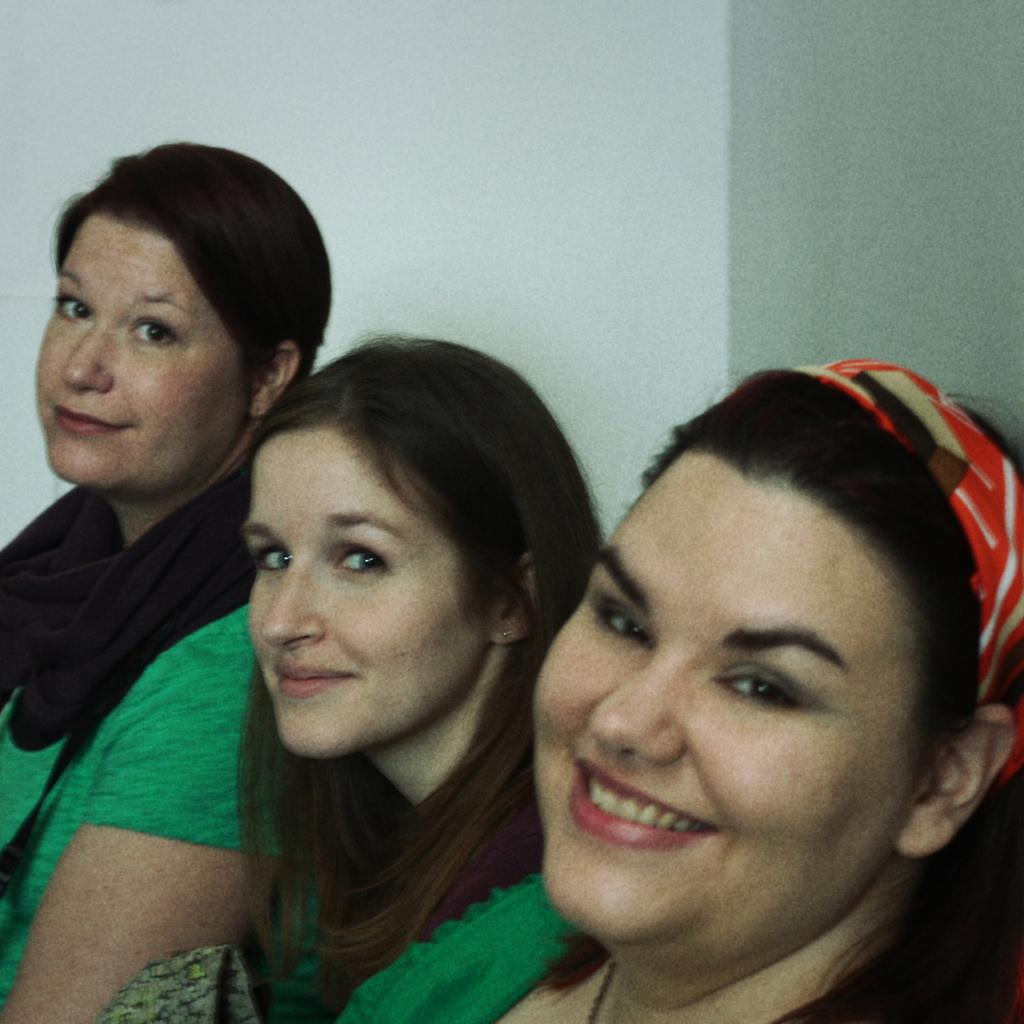How many people are present in the image? There are three people in the image. What expressions do the people have on their faces? The people are wearing smiles on their faces. What can be seen in the background of the image? There is a wall visible in the background of the image. What type of spark can be seen coming from the girls' hands in the image? There are no girls present in the image, and therefore no sparks can be seen coming from their hands. 